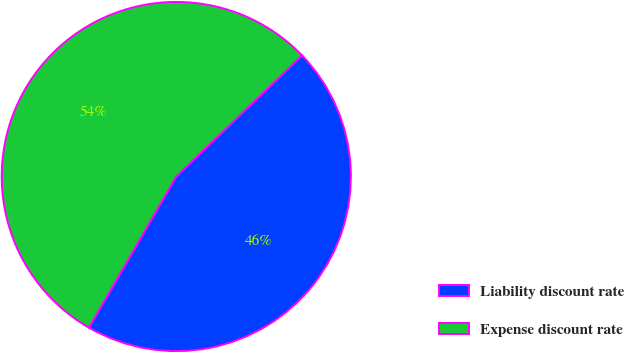Convert chart. <chart><loc_0><loc_0><loc_500><loc_500><pie_chart><fcel>Liability discount rate<fcel>Expense discount rate<nl><fcel>45.54%<fcel>54.46%<nl></chart> 